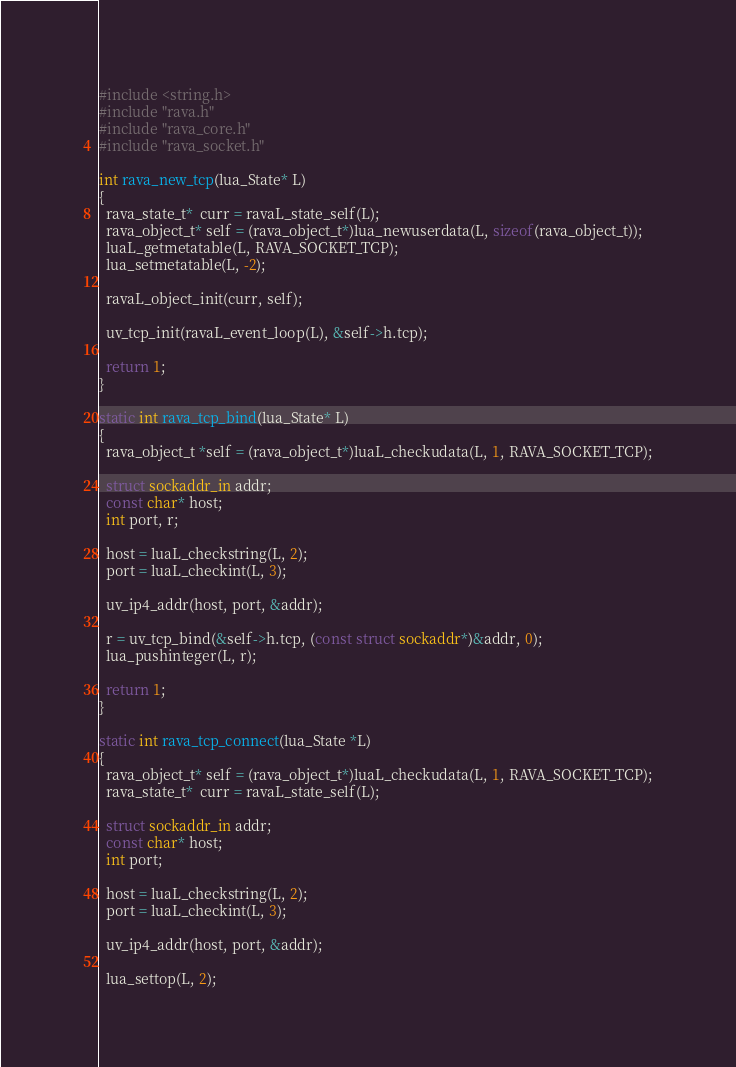<code> <loc_0><loc_0><loc_500><loc_500><_C_>#include <string.h>
#include "rava.h"
#include "rava_core.h"
#include "rava_socket.h"

int rava_new_tcp(lua_State* L)
{
  rava_state_t*  curr = ravaL_state_self(L);
  rava_object_t* self = (rava_object_t*)lua_newuserdata(L, sizeof(rava_object_t));
  luaL_getmetatable(L, RAVA_SOCKET_TCP);
  lua_setmetatable(L, -2);

  ravaL_object_init(curr, self);

  uv_tcp_init(ravaL_event_loop(L), &self->h.tcp);

  return 1;
}

static int rava_tcp_bind(lua_State* L)
{
  rava_object_t *self = (rava_object_t*)luaL_checkudata(L, 1, RAVA_SOCKET_TCP);

  struct sockaddr_in addr;
  const char* host;
  int port, r;

  host = luaL_checkstring(L, 2);
  port = luaL_checkint(L, 3);

  uv_ip4_addr(host, port, &addr);

  r = uv_tcp_bind(&self->h.tcp, (const struct sockaddr*)&addr, 0);
  lua_pushinteger(L, r);

  return 1;
}

static int rava_tcp_connect(lua_State *L)
{
  rava_object_t* self = (rava_object_t*)luaL_checkudata(L, 1, RAVA_SOCKET_TCP);
  rava_state_t*  curr = ravaL_state_self(L);

  struct sockaddr_in addr;
  const char* host;
  int port;

  host = luaL_checkstring(L, 2);
  port = luaL_checkint(L, 3);

  uv_ip4_addr(host, port, &addr);

  lua_settop(L, 2);
</code> 